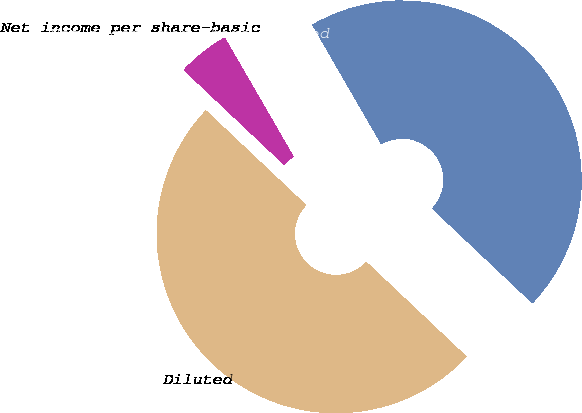Convert chart. <chart><loc_0><loc_0><loc_500><loc_500><pie_chart><fcel>Net income per share-basic<fcel>Net income per share-diluted<fcel>Basic<fcel>Diluted<nl><fcel>0.0%<fcel>4.61%<fcel>45.39%<fcel>50.0%<nl></chart> 